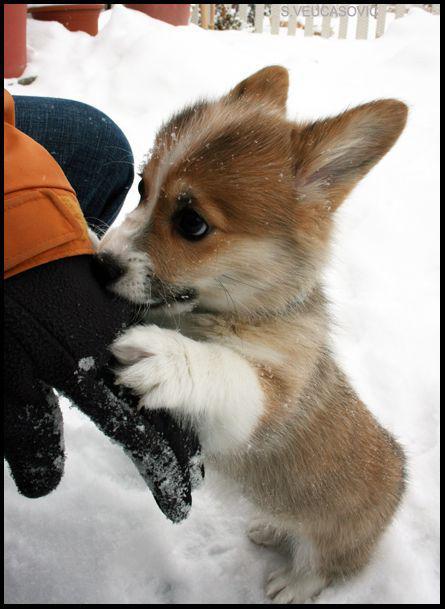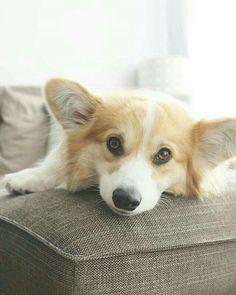The first image is the image on the left, the second image is the image on the right. Examine the images to the left and right. Is the description "There are more than four dogs." accurate? Answer yes or no. No. The first image is the image on the left, the second image is the image on the right. For the images displayed, is the sentence "At least one hand is touching a dog, and at least one image contains a single dog with upright ears." factually correct? Answer yes or no. Yes. 